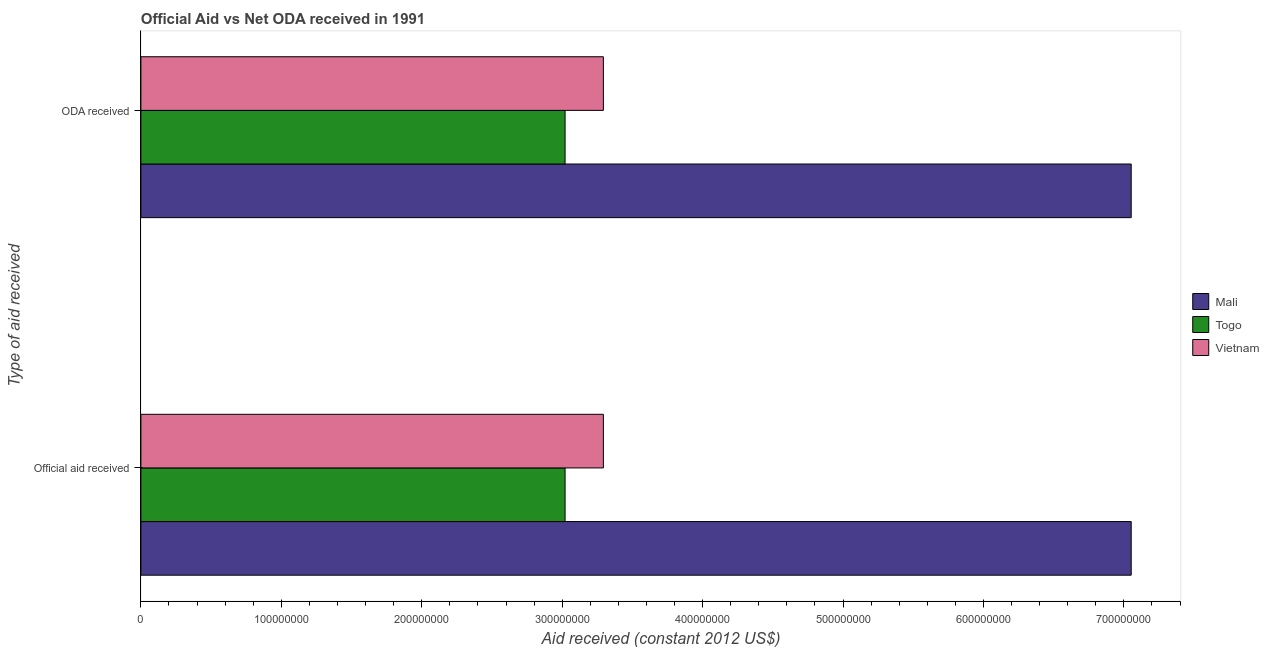Are the number of bars per tick equal to the number of legend labels?
Provide a short and direct response. Yes. Are the number of bars on each tick of the Y-axis equal?
Offer a very short reply. Yes. How many bars are there on the 1st tick from the top?
Your answer should be very brief. 3. What is the label of the 1st group of bars from the top?
Offer a terse response. ODA received. What is the oda received in Mali?
Keep it short and to the point. 7.05e+08. Across all countries, what is the maximum official aid received?
Your response must be concise. 7.05e+08. Across all countries, what is the minimum oda received?
Your answer should be very brief. 3.02e+08. In which country was the oda received maximum?
Your answer should be very brief. Mali. In which country was the official aid received minimum?
Offer a terse response. Togo. What is the total official aid received in the graph?
Your answer should be very brief. 1.34e+09. What is the difference between the oda received in Mali and that in Vietnam?
Your response must be concise. 3.76e+08. What is the difference between the oda received in Vietnam and the official aid received in Mali?
Make the answer very short. -3.76e+08. What is the average oda received per country?
Make the answer very short. 4.46e+08. What is the ratio of the official aid received in Vietnam to that in Mali?
Your response must be concise. 0.47. In how many countries, is the oda received greater than the average oda received taken over all countries?
Offer a very short reply. 1. What does the 2nd bar from the top in Official aid received represents?
Keep it short and to the point. Togo. What does the 1st bar from the bottom in Official aid received represents?
Your answer should be compact. Mali. How many bars are there?
Ensure brevity in your answer.  6. How many countries are there in the graph?
Your answer should be compact. 3. What is the difference between two consecutive major ticks on the X-axis?
Provide a short and direct response. 1.00e+08. Does the graph contain any zero values?
Make the answer very short. No. How many legend labels are there?
Give a very brief answer. 3. How are the legend labels stacked?
Ensure brevity in your answer.  Vertical. What is the title of the graph?
Offer a terse response. Official Aid vs Net ODA received in 1991 . Does "Denmark" appear as one of the legend labels in the graph?
Offer a very short reply. No. What is the label or title of the X-axis?
Your answer should be very brief. Aid received (constant 2012 US$). What is the label or title of the Y-axis?
Keep it short and to the point. Type of aid received. What is the Aid received (constant 2012 US$) of Mali in Official aid received?
Your answer should be very brief. 7.05e+08. What is the Aid received (constant 2012 US$) in Togo in Official aid received?
Make the answer very short. 3.02e+08. What is the Aid received (constant 2012 US$) of Vietnam in Official aid received?
Offer a very short reply. 3.29e+08. What is the Aid received (constant 2012 US$) in Mali in ODA received?
Give a very brief answer. 7.05e+08. What is the Aid received (constant 2012 US$) in Togo in ODA received?
Your response must be concise. 3.02e+08. What is the Aid received (constant 2012 US$) of Vietnam in ODA received?
Your response must be concise. 3.29e+08. Across all Type of aid received, what is the maximum Aid received (constant 2012 US$) in Mali?
Your answer should be compact. 7.05e+08. Across all Type of aid received, what is the maximum Aid received (constant 2012 US$) of Togo?
Your answer should be very brief. 3.02e+08. Across all Type of aid received, what is the maximum Aid received (constant 2012 US$) of Vietnam?
Your response must be concise. 3.29e+08. Across all Type of aid received, what is the minimum Aid received (constant 2012 US$) in Mali?
Offer a very short reply. 7.05e+08. Across all Type of aid received, what is the minimum Aid received (constant 2012 US$) in Togo?
Keep it short and to the point. 3.02e+08. Across all Type of aid received, what is the minimum Aid received (constant 2012 US$) in Vietnam?
Your answer should be very brief. 3.29e+08. What is the total Aid received (constant 2012 US$) in Mali in the graph?
Provide a short and direct response. 1.41e+09. What is the total Aid received (constant 2012 US$) in Togo in the graph?
Provide a short and direct response. 6.04e+08. What is the total Aid received (constant 2012 US$) of Vietnam in the graph?
Provide a succinct answer. 6.59e+08. What is the difference between the Aid received (constant 2012 US$) of Mali in Official aid received and that in ODA received?
Your answer should be very brief. 0. What is the difference between the Aid received (constant 2012 US$) in Vietnam in Official aid received and that in ODA received?
Offer a terse response. 0. What is the difference between the Aid received (constant 2012 US$) in Mali in Official aid received and the Aid received (constant 2012 US$) in Togo in ODA received?
Your answer should be very brief. 4.03e+08. What is the difference between the Aid received (constant 2012 US$) in Mali in Official aid received and the Aid received (constant 2012 US$) in Vietnam in ODA received?
Offer a very short reply. 3.76e+08. What is the difference between the Aid received (constant 2012 US$) of Togo in Official aid received and the Aid received (constant 2012 US$) of Vietnam in ODA received?
Make the answer very short. -2.73e+07. What is the average Aid received (constant 2012 US$) of Mali per Type of aid received?
Provide a short and direct response. 7.05e+08. What is the average Aid received (constant 2012 US$) in Togo per Type of aid received?
Your answer should be compact. 3.02e+08. What is the average Aid received (constant 2012 US$) in Vietnam per Type of aid received?
Provide a short and direct response. 3.29e+08. What is the difference between the Aid received (constant 2012 US$) of Mali and Aid received (constant 2012 US$) of Togo in Official aid received?
Offer a terse response. 4.03e+08. What is the difference between the Aid received (constant 2012 US$) in Mali and Aid received (constant 2012 US$) in Vietnam in Official aid received?
Ensure brevity in your answer.  3.76e+08. What is the difference between the Aid received (constant 2012 US$) in Togo and Aid received (constant 2012 US$) in Vietnam in Official aid received?
Provide a succinct answer. -2.73e+07. What is the difference between the Aid received (constant 2012 US$) in Mali and Aid received (constant 2012 US$) in Togo in ODA received?
Provide a short and direct response. 4.03e+08. What is the difference between the Aid received (constant 2012 US$) of Mali and Aid received (constant 2012 US$) of Vietnam in ODA received?
Provide a succinct answer. 3.76e+08. What is the difference between the Aid received (constant 2012 US$) in Togo and Aid received (constant 2012 US$) in Vietnam in ODA received?
Make the answer very short. -2.73e+07. What is the ratio of the Aid received (constant 2012 US$) in Togo in Official aid received to that in ODA received?
Make the answer very short. 1. What is the ratio of the Aid received (constant 2012 US$) of Vietnam in Official aid received to that in ODA received?
Make the answer very short. 1. What is the difference between the highest and the second highest Aid received (constant 2012 US$) of Togo?
Ensure brevity in your answer.  0. What is the difference between the highest and the lowest Aid received (constant 2012 US$) of Togo?
Ensure brevity in your answer.  0. What is the difference between the highest and the lowest Aid received (constant 2012 US$) of Vietnam?
Provide a short and direct response. 0. 